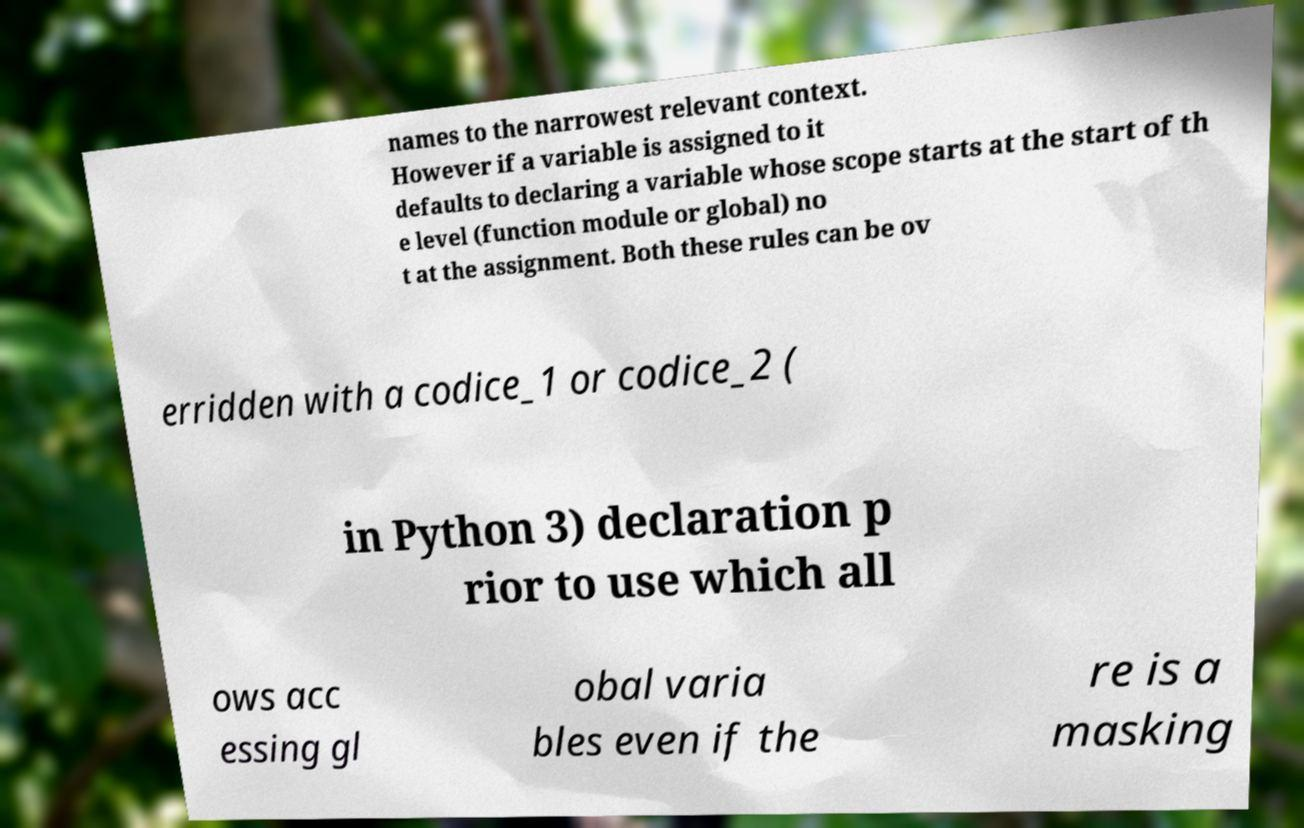What messages or text are displayed in this image? I need them in a readable, typed format. names to the narrowest relevant context. However if a variable is assigned to it defaults to declaring a variable whose scope starts at the start of th e level (function module or global) no t at the assignment. Both these rules can be ov erridden with a codice_1 or codice_2 ( in Python 3) declaration p rior to use which all ows acc essing gl obal varia bles even if the re is a masking 